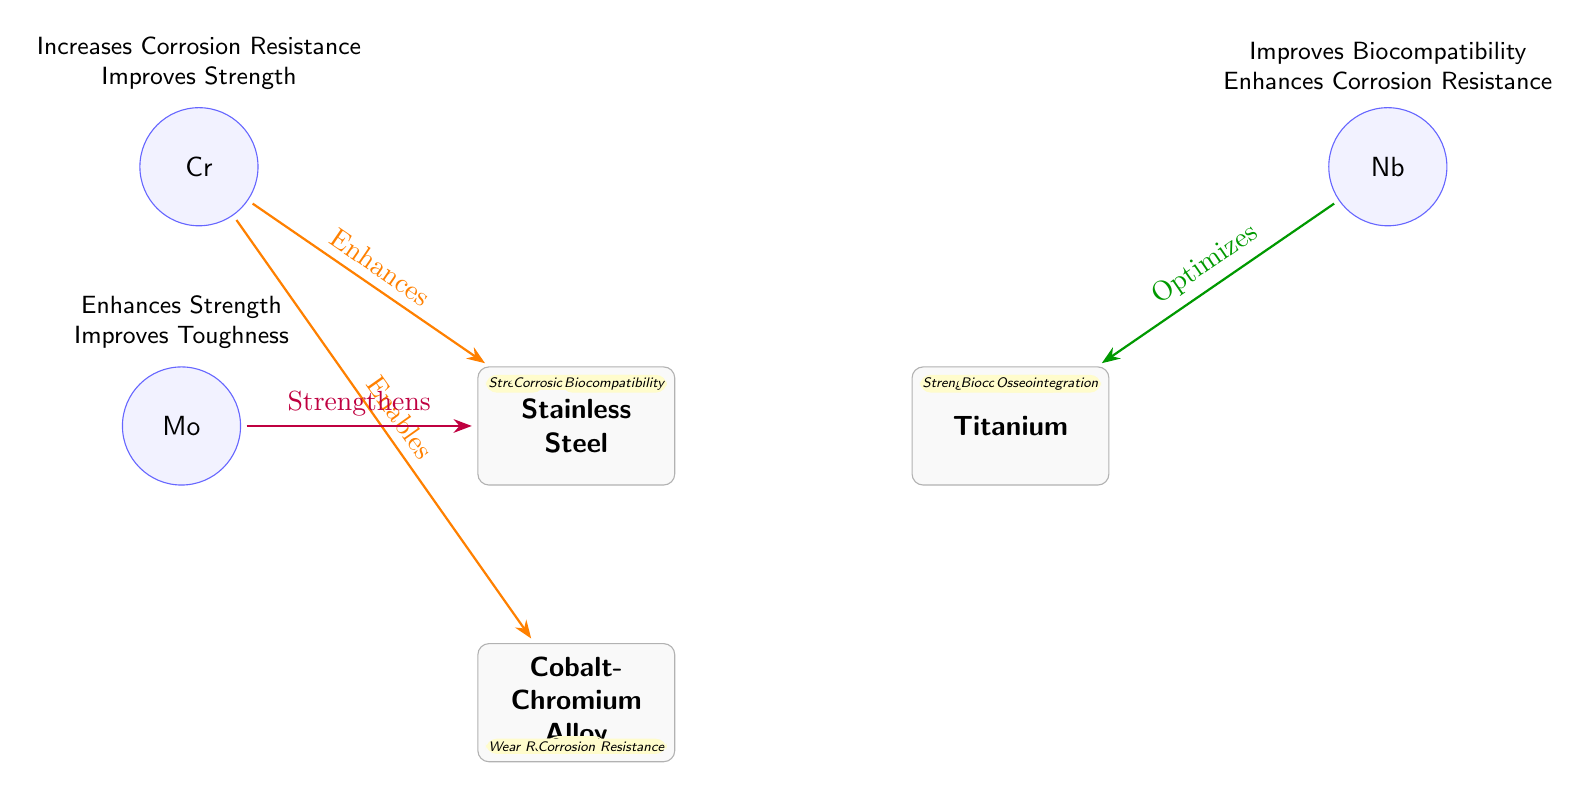What are the alloying elements represented in the diagram? The diagram shows three alloying elements which are Chromium (Cr), Molybdenum (Mo), and Niobium (Nb) that are associated with different metals.
Answer: Chromium, Molybdenum, Niobium How many properties are displayed for Titanium in the diagram? The diagram lists three properties associated with Titanium: Strength, Biocompatibility, and Osseointegration.
Answer: Three What effect does Chromium have on Stainless Steel? The effect of Chromium on Stainless Steel is indicated as "Increases Corrosion Resistance" and "Improves Strength."
Answer: Increases Corrosion Resistance, Improves Strength Which metal's properties include Wear Resistance? The metal Cobalt-Chromium Alloy is shown to have the property of Wear Resistance in the diagram.
Answer: Cobalt-Chromium Alloy What is the relationship between Molybdenum and Stainless Steel? Molybdenum is indicated to "Strengthen" Stainless Steel, thereby improving its properties.
Answer: Strengthens What unique property does Niobium enhance for Titanium? The diagram states that Niobium "Improves Biocompatibility" for Titanium.
Answer: Improves Biocompatibility Which alloying element is shown to enhance the strength of both Stainless Steel and Cobalt-Chromium Alloy? Chromium is indicated in the diagram to enhance the strength of both metals, Stainless Steel and Cobalt-Chromium Alloy.
Answer: Chromium What are the three properties of Cobalt-Chromium Alloy listed in the diagram? The properties of Cobalt-Chromium Alloy are Wear Resistance, Strength, and Corrosion Resistance as shown in the diagram.
Answer: Wear Resistance, Strength, Corrosion Resistance What effect does Niobium have on Titanium in terms of corrosion resistance? Niobium is said to "Enhance Corrosion Resistance" in relation to Titanium according to the diagram, suggesting a positive impact on its durability against corrosive environments.
Answer: Enhances Corrosion Resistance 